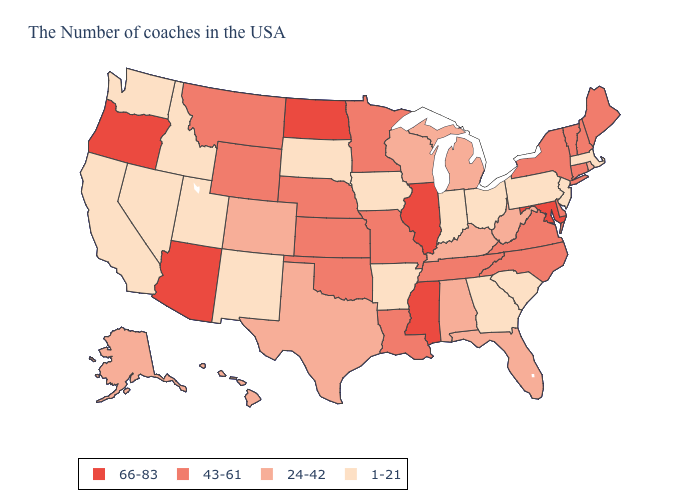What is the lowest value in states that border Massachusetts?
Write a very short answer. 24-42. What is the lowest value in the USA?
Keep it brief. 1-21. Among the states that border New Mexico , does Arizona have the highest value?
Be succinct. Yes. Does Minnesota have a lower value than Oregon?
Keep it brief. Yes. Does North Carolina have the highest value in the South?
Quick response, please. No. What is the value of Delaware?
Answer briefly. 43-61. What is the value of Wisconsin?
Concise answer only. 24-42. What is the value of Washington?
Quick response, please. 1-21. Does Pennsylvania have the highest value in the Northeast?
Quick response, please. No. Does the first symbol in the legend represent the smallest category?
Quick response, please. No. What is the lowest value in the USA?
Answer briefly. 1-21. Name the states that have a value in the range 24-42?
Give a very brief answer. Rhode Island, West Virginia, Florida, Michigan, Kentucky, Alabama, Wisconsin, Texas, Colorado, Alaska, Hawaii. Does Indiana have the lowest value in the MidWest?
Give a very brief answer. Yes. Among the states that border Nebraska , which have the lowest value?
Write a very short answer. Iowa, South Dakota. Name the states that have a value in the range 66-83?
Short answer required. Maryland, Illinois, Mississippi, North Dakota, Arizona, Oregon. 